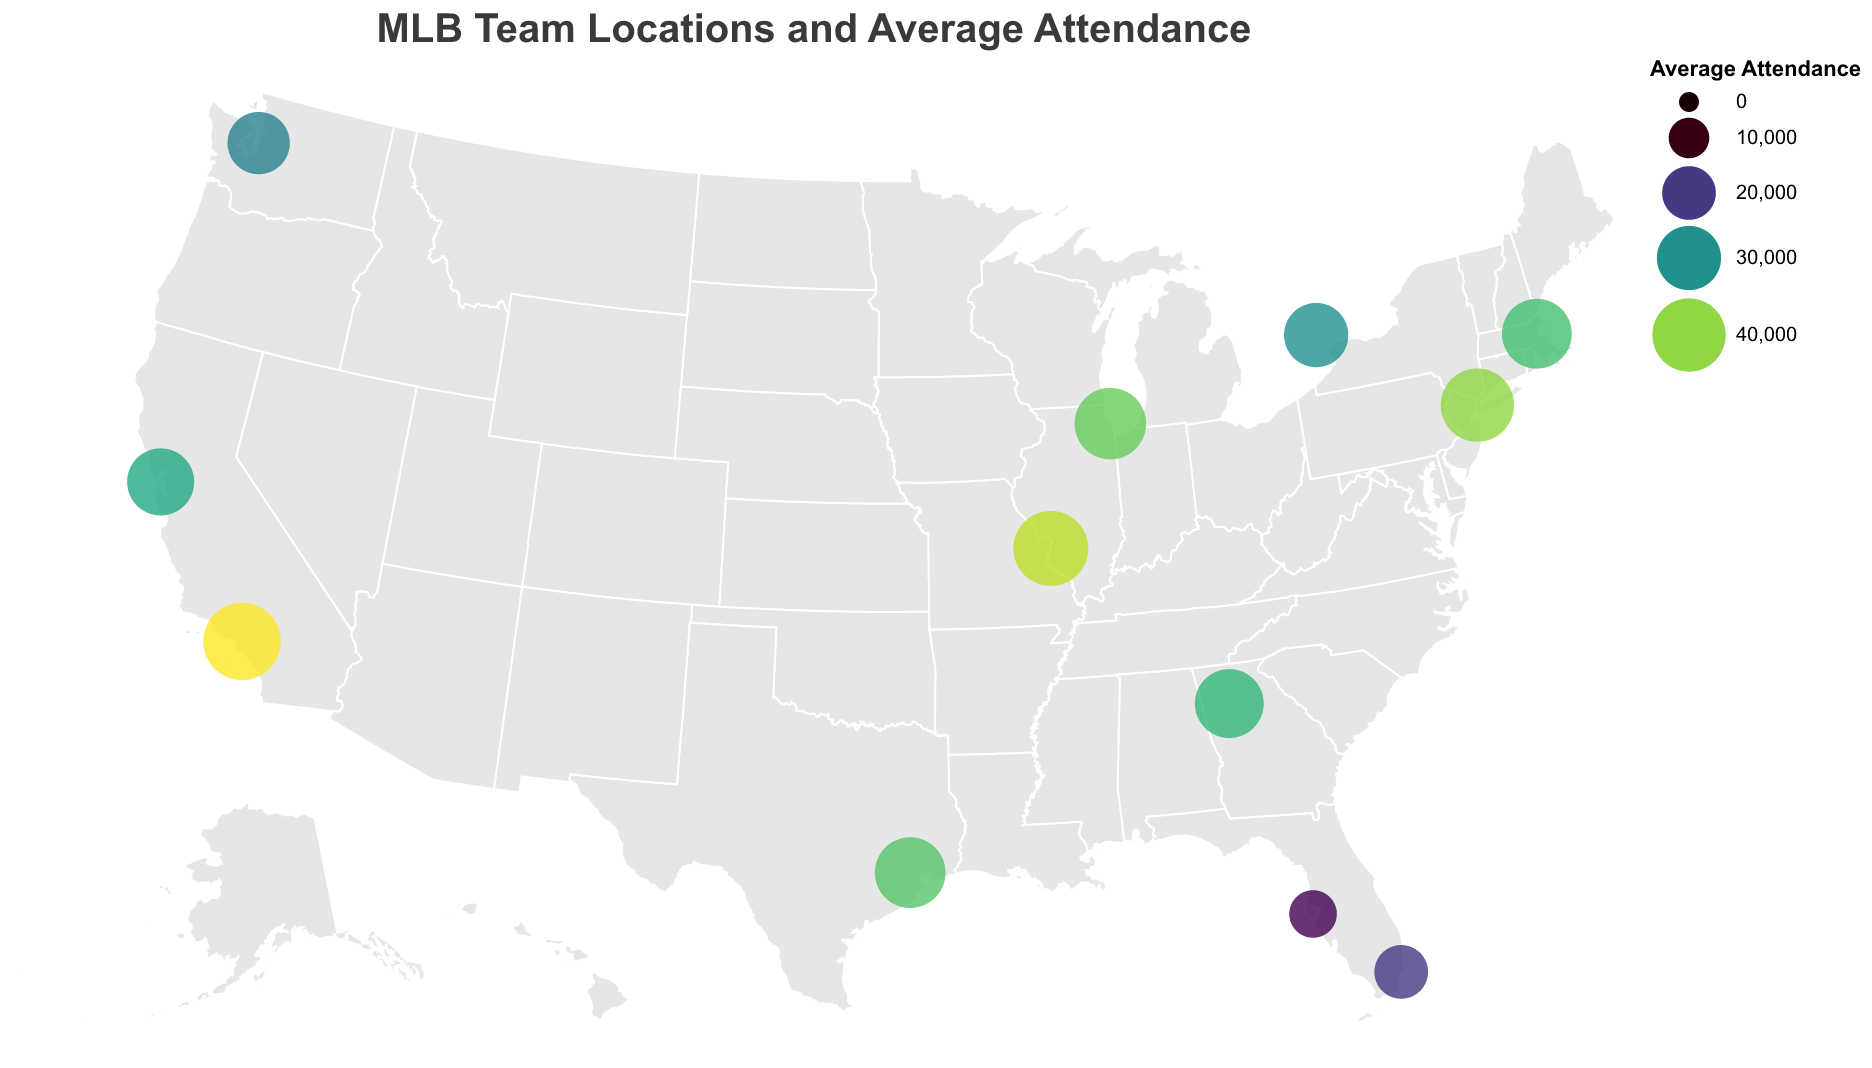What's the title of the figure? The title is prominently displayed at the top of the figure and serves as a summary of what the plot represents. The text is "MLB Team Locations and Average Attendance".
Answer: MLB Team Locations and Average Attendance How many teams are represented in the figure? Count each circle on the map to determine the number of unique MLB teams represented in the plot. There are 12 circles representing 12 different teams.
Answer: 12 Which team has the highest average attendance? Look for the largest circle and/or the darkest color on the map. The tooltip will also indicate the team. The Los Angeles Dodgers have the highest average attendance at 45,000.
Answer: Los Angeles Dodgers Which team has the lowest average attendance? Identify the smallest circle and/or the lightest color. The tooltip confirms that the Tampa Bay Rays have the lowest average attendance at 15,000.
Answer: Tampa Bay Rays What's the average attendance for the New York Yankees? Hover over or check the tooltip for the circle located at the coordinates for New York (around Latitude 40.8296, Longitude -73.9262). It shows an average attendance of 40,000.
Answer: 40,000 What is the difference in average attendance between the Houston Astros and the Miami Marlins? Find the average attendance for both teams: Houston Astros is 37,000 and Miami Marlins is 20,000. Subtract to find the difference: 37,000 - 20,000 = 17,000.
Answer: 17,000 Which state has more MLB teams, California or Florida? Count the number of MLB teams in each state by looking at the circles in California and Florida. California has 3 teams (Dodgers, Giants, Athletics) whereas Florida has 2 teams (Marlins, Rays).
Answer: California Which team in the Midwest has the highest attendance? Identify the teams in the Midwest region first: Chicago Cubs (38,000) and St. Louis Cardinals (42,000). Compare their average attendance to find that St. Louis Cardinals has the highest attendance.
Answer: St. Louis Cardinals How many teams have an average attendance greater than 35,000? Count the circles with an average attendance greater than 35,000: Yankees, Dodgers, Cubs, Red Sox, Cardinals, and Astros. This gives a total of 6 teams.
Answer: 6 Which three teams have the closest average attendance? Examine the attendance values and find which three are closest in value: Red Sox (36,000), Astros (37,000), and Cubs (38,000) are the closest. The difference between them is within 2,000.
Answer: Red Sox, Astros, Cubs 